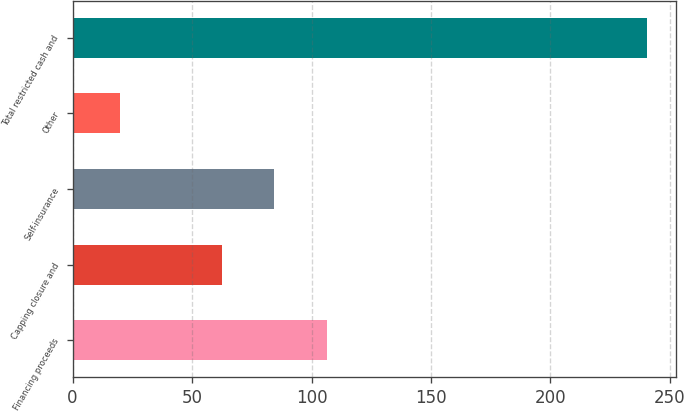<chart> <loc_0><loc_0><loc_500><loc_500><bar_chart><fcel>Financing proceeds<fcel>Capping closure and<fcel>Self-insurance<fcel>Other<fcel>Total restricted cash and<nl><fcel>106.52<fcel>62.4<fcel>84.46<fcel>19.9<fcel>240.5<nl></chart> 